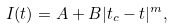Convert formula to latex. <formula><loc_0><loc_0><loc_500><loc_500>I ( t ) = A + B | t _ { c } - t | ^ { m } ,</formula> 